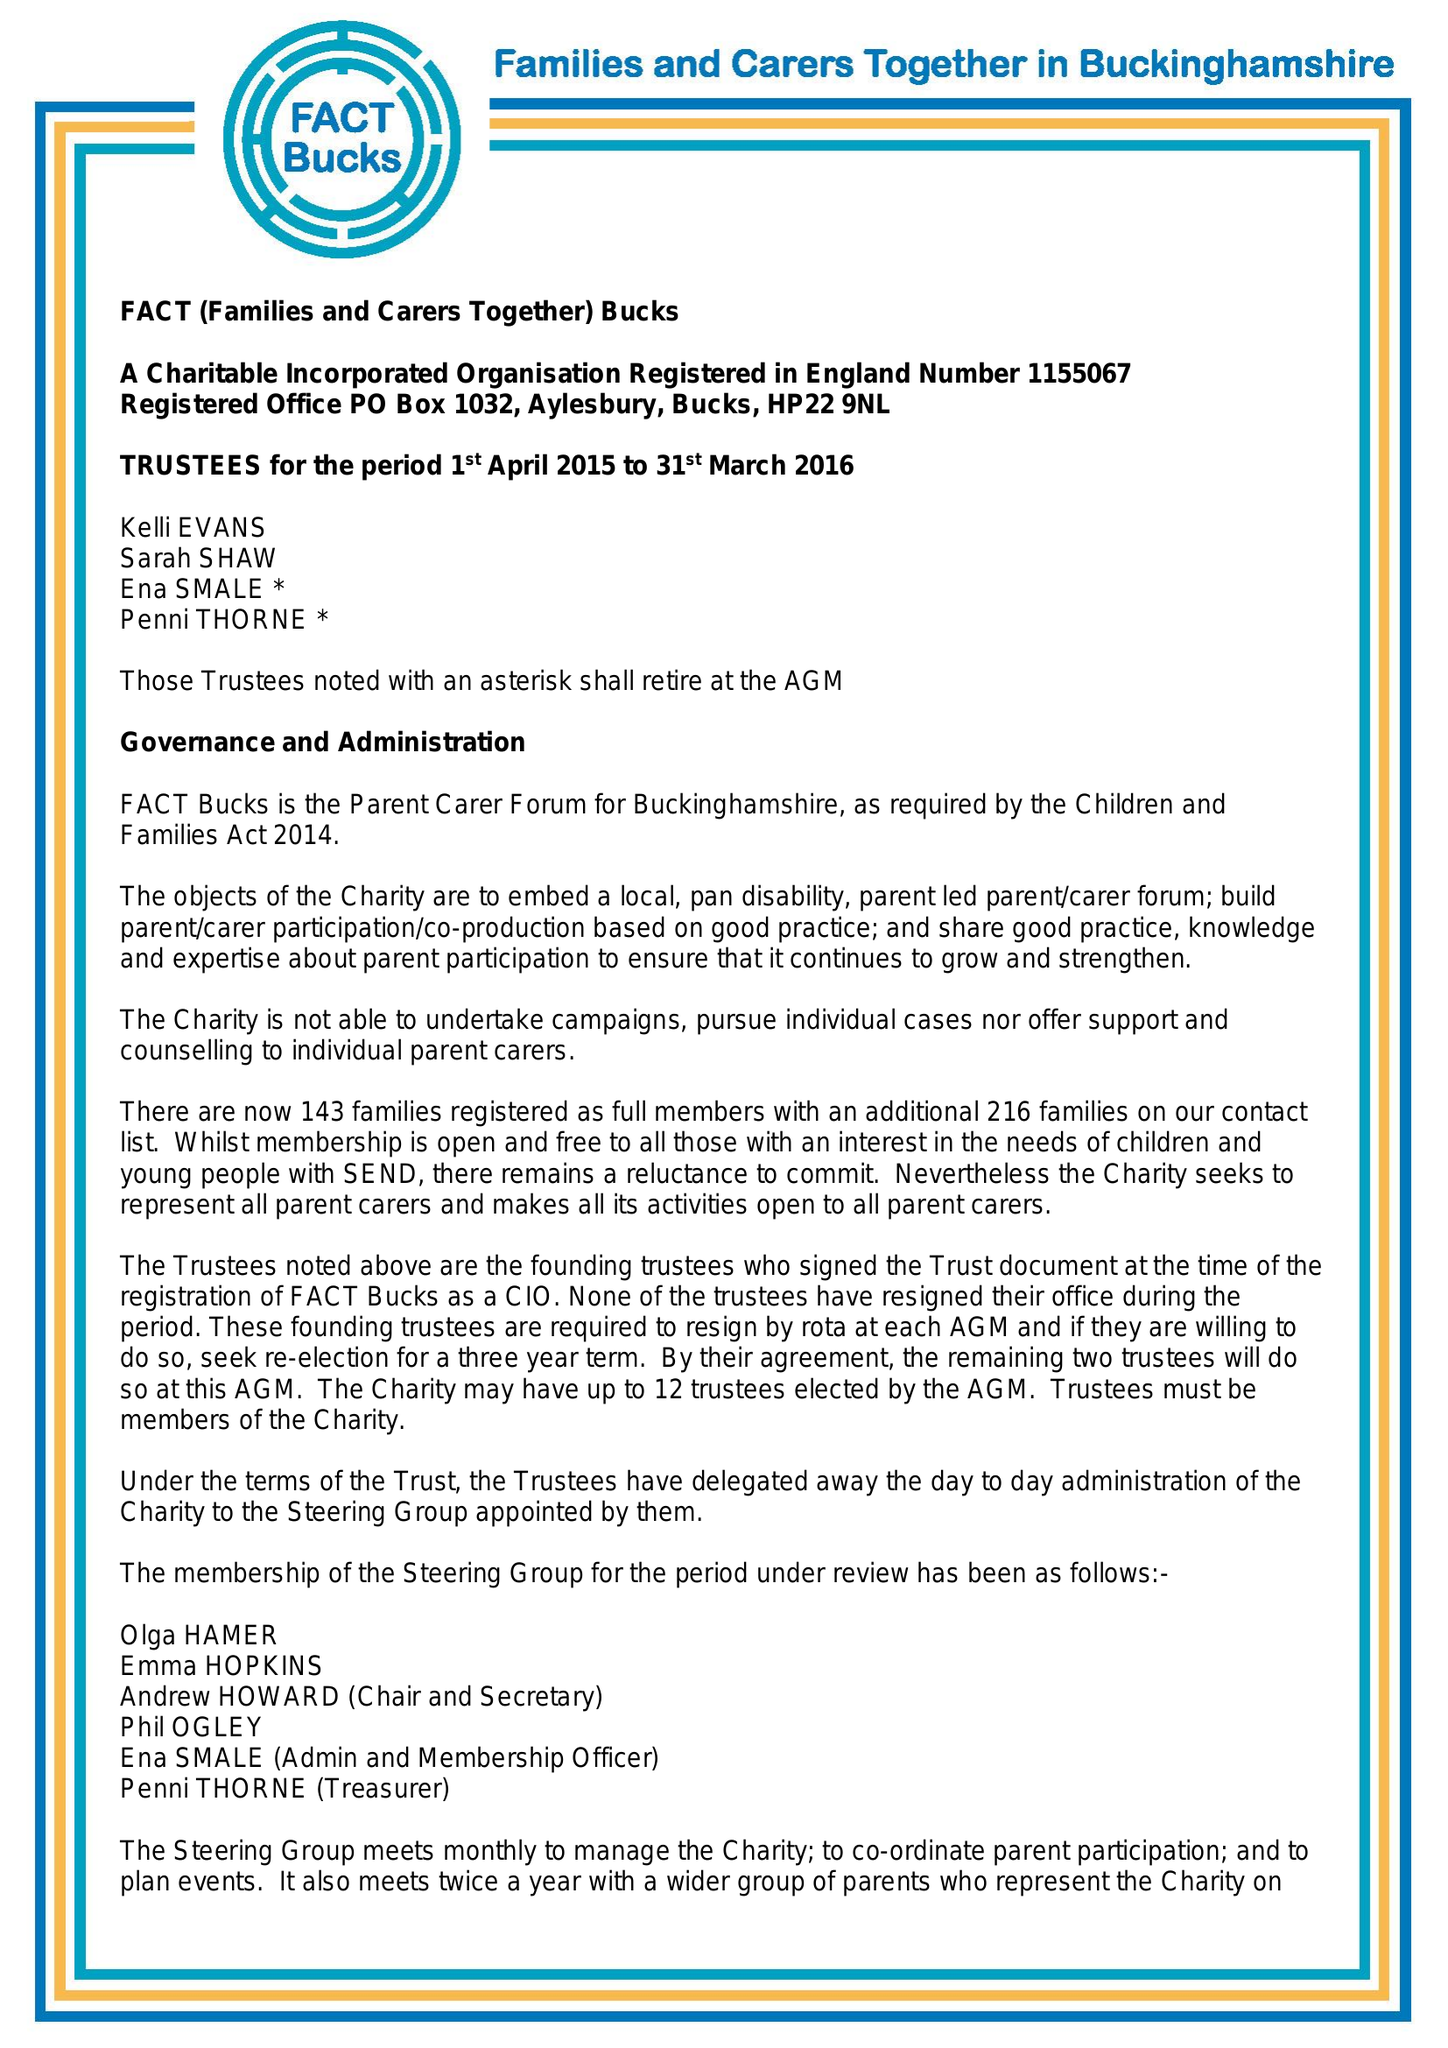What is the value for the charity_number?
Answer the question using a single word or phrase. 1155067 